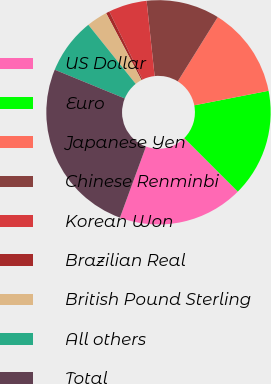Convert chart to OTSL. <chart><loc_0><loc_0><loc_500><loc_500><pie_chart><fcel>US Dollar<fcel>Euro<fcel>Japanese Yen<fcel>Chinese Renminbi<fcel>Korean Won<fcel>Brazilian Real<fcel>British Pound Sterling<fcel>All others<fcel>Total<nl><fcel>18.08%<fcel>15.57%<fcel>13.06%<fcel>10.55%<fcel>5.53%<fcel>0.51%<fcel>3.02%<fcel>8.04%<fcel>25.61%<nl></chart> 